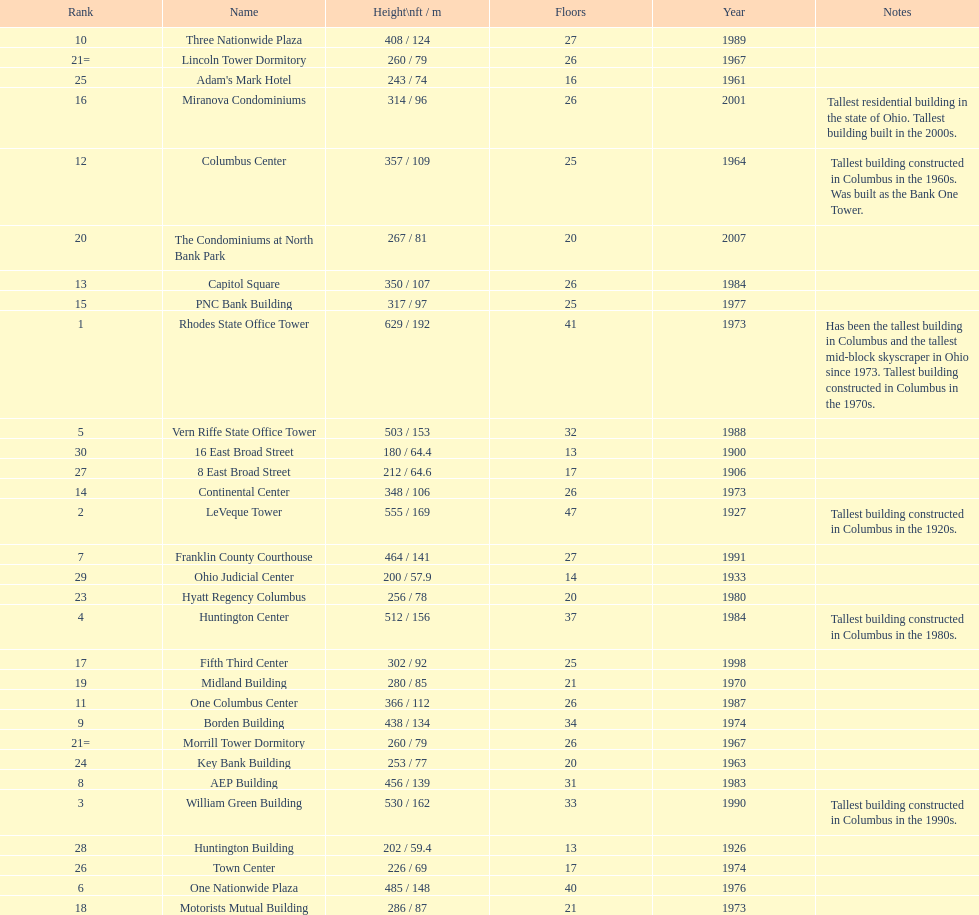Which buildings are taller than 500 ft? Rhodes State Office Tower, LeVeque Tower, William Green Building, Huntington Center, Vern Riffe State Office Tower. 